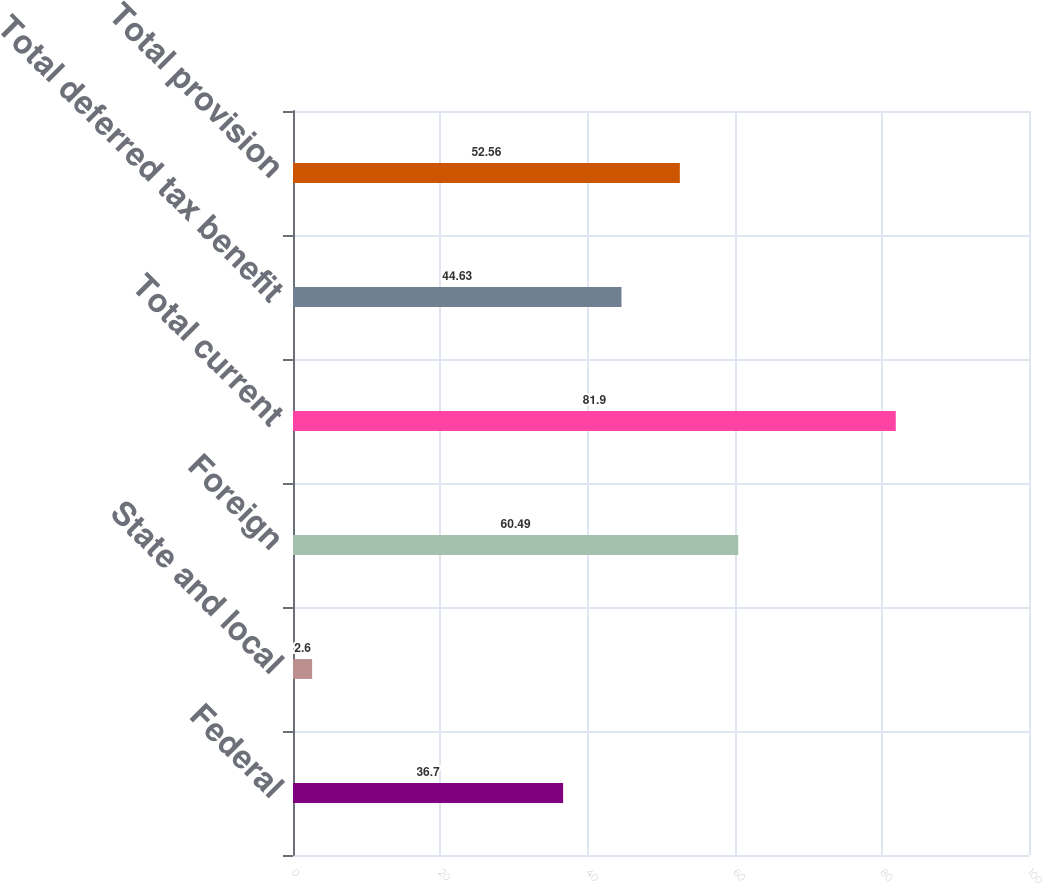<chart> <loc_0><loc_0><loc_500><loc_500><bar_chart><fcel>Federal<fcel>State and local<fcel>Foreign<fcel>Total current<fcel>Total deferred tax benefit<fcel>Total provision<nl><fcel>36.7<fcel>2.6<fcel>60.49<fcel>81.9<fcel>44.63<fcel>52.56<nl></chart> 